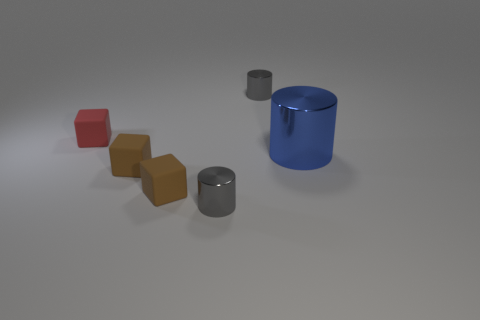Is there any other thing that has the same color as the big metallic thing?
Keep it short and to the point. No. There is a small thing that is right of the red rubber block and behind the blue metal cylinder; what is its material?
Ensure brevity in your answer.  Metal. What shape is the small gray thing that is in front of the red rubber object?
Provide a short and direct response. Cylinder. What is the shape of the small gray thing in front of the rubber object behind the blue shiny thing?
Give a very brief answer. Cylinder. Is there a small gray thing that has the same shape as the blue thing?
Ensure brevity in your answer.  Yes. There is a small gray metal cylinder to the right of the metallic cylinder that is in front of the blue cylinder; is there a block that is in front of it?
Your answer should be very brief. Yes. Is there a gray shiny object that has the same size as the red matte block?
Offer a terse response. Yes. There is a metallic cylinder that is behind the large blue shiny thing; what is its size?
Offer a very short reply. Small. The big object on the right side of the tiny gray cylinder in front of the object behind the small red matte thing is what color?
Offer a very short reply. Blue. There is a cylinder that is right of the tiny metal cylinder that is behind the tiny red matte block; what color is it?
Keep it short and to the point. Blue. 